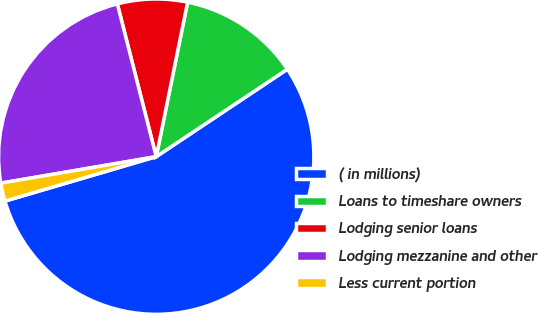Convert chart. <chart><loc_0><loc_0><loc_500><loc_500><pie_chart><fcel>( in millions)<fcel>Loans to timeshare owners<fcel>Lodging senior loans<fcel>Lodging mezzanine and other<fcel>Less current portion<nl><fcel>54.82%<fcel>12.45%<fcel>7.16%<fcel>23.72%<fcel>1.86%<nl></chart> 